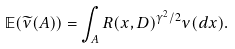<formula> <loc_0><loc_0><loc_500><loc_500>\mathbb { E } ( \widetilde { \nu } ( A ) ) = \int _ { A } R ( x , D ) ^ { \gamma ^ { 2 } / 2 } \nu ( d x ) .</formula> 